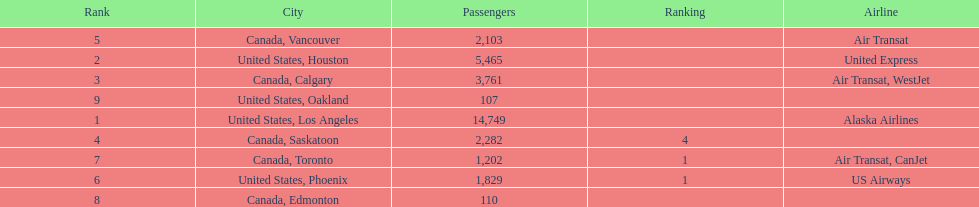The least number of passengers came from which city United States, Oakland. 